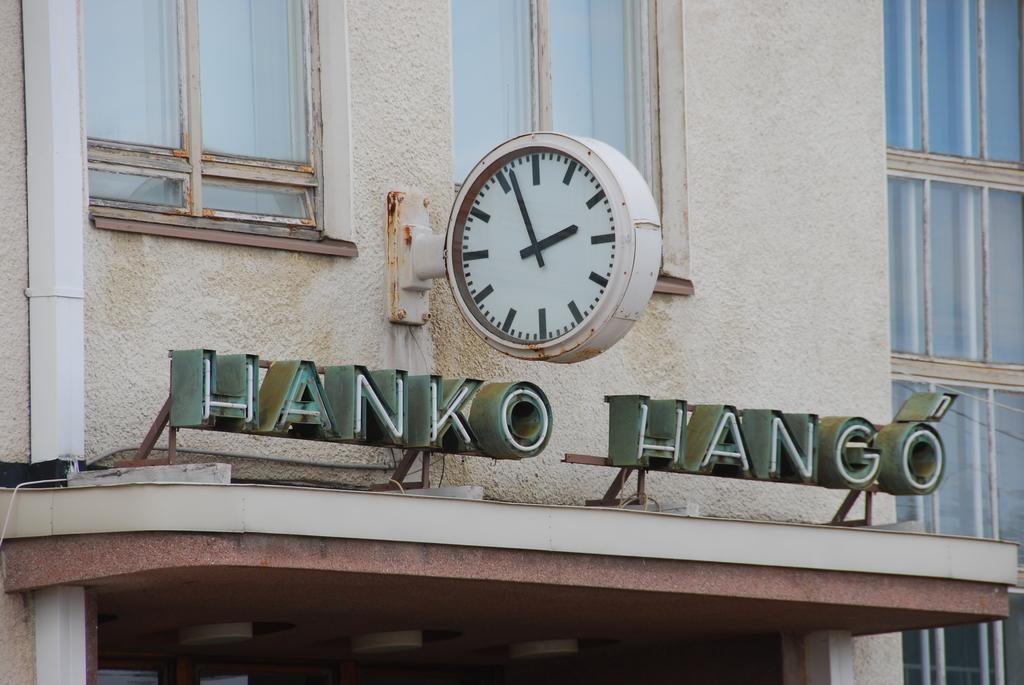<image>
Relay a brief, clear account of the picture shown. A sign for Hanko Hango situated above a building entrance. 